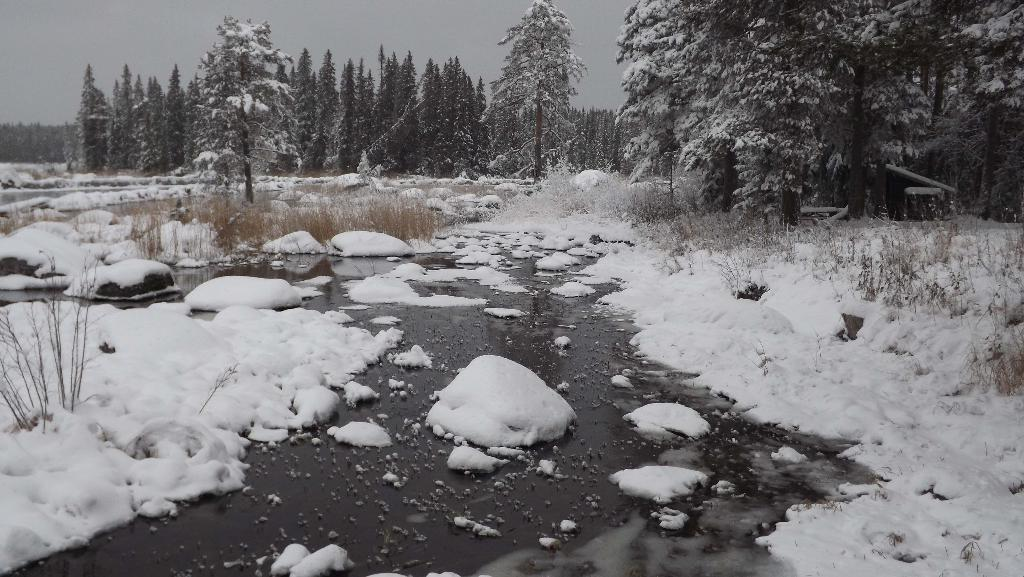What is present at the bottom of the image? There is water at the bottom of the image. What type of precipitation can be seen in the image? There is snow in the image. What type of vegetation is present in the image? There is grass in the image. What can be seen in the background of the image? There are trees in the background of the image. What is visible at the top of the image? The sky is visible at the top of the image. What type of lace can be seen on the trees in the image? There is no lace present on the trees in the image; they are covered in snow. What color is the orange in the image? There is no orange present in the image. 